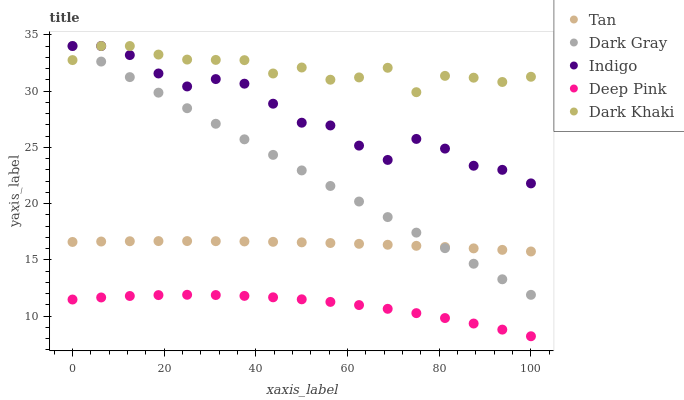Does Deep Pink have the minimum area under the curve?
Answer yes or no. Yes. Does Dark Khaki have the maximum area under the curve?
Answer yes or no. Yes. Does Tan have the minimum area under the curve?
Answer yes or no. No. Does Tan have the maximum area under the curve?
Answer yes or no. No. Is Dark Gray the smoothest?
Answer yes or no. Yes. Is Dark Khaki the roughest?
Answer yes or no. Yes. Is Tan the smoothest?
Answer yes or no. No. Is Tan the roughest?
Answer yes or no. No. Does Deep Pink have the lowest value?
Answer yes or no. Yes. Does Tan have the lowest value?
Answer yes or no. No. Does Indigo have the highest value?
Answer yes or no. Yes. Does Tan have the highest value?
Answer yes or no. No. Is Deep Pink less than Indigo?
Answer yes or no. Yes. Is Dark Khaki greater than Tan?
Answer yes or no. Yes. Does Indigo intersect Dark Khaki?
Answer yes or no. Yes. Is Indigo less than Dark Khaki?
Answer yes or no. No. Is Indigo greater than Dark Khaki?
Answer yes or no. No. Does Deep Pink intersect Indigo?
Answer yes or no. No. 